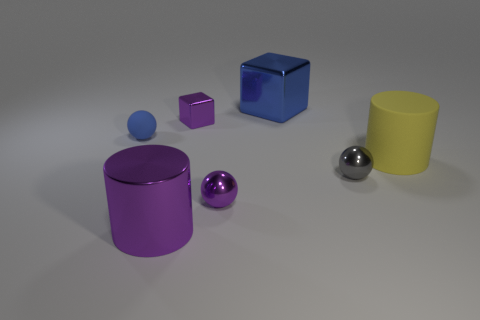Does the small shiny block have the same color as the shiny cylinder?
Your response must be concise. Yes. Is there a block that has the same color as the tiny rubber ball?
Offer a terse response. Yes. Is the large thing that is in front of the gray thing made of the same material as the tiny purple object behind the blue rubber object?
Provide a succinct answer. Yes. What color is the rubber cylinder?
Give a very brief answer. Yellow. There is a cylinder that is on the left side of the rubber object that is on the right side of the cylinder that is to the left of the yellow matte thing; what is its size?
Offer a very short reply. Large. How many other objects are there of the same size as the blue metallic block?
Your answer should be very brief. 2. What number of small gray objects have the same material as the blue block?
Make the answer very short. 1. What is the shape of the purple thing behind the small matte thing?
Ensure brevity in your answer.  Cube. Do the small blue ball and the tiny ball that is in front of the small gray shiny object have the same material?
Give a very brief answer. No. Are any small things visible?
Provide a succinct answer. Yes. 